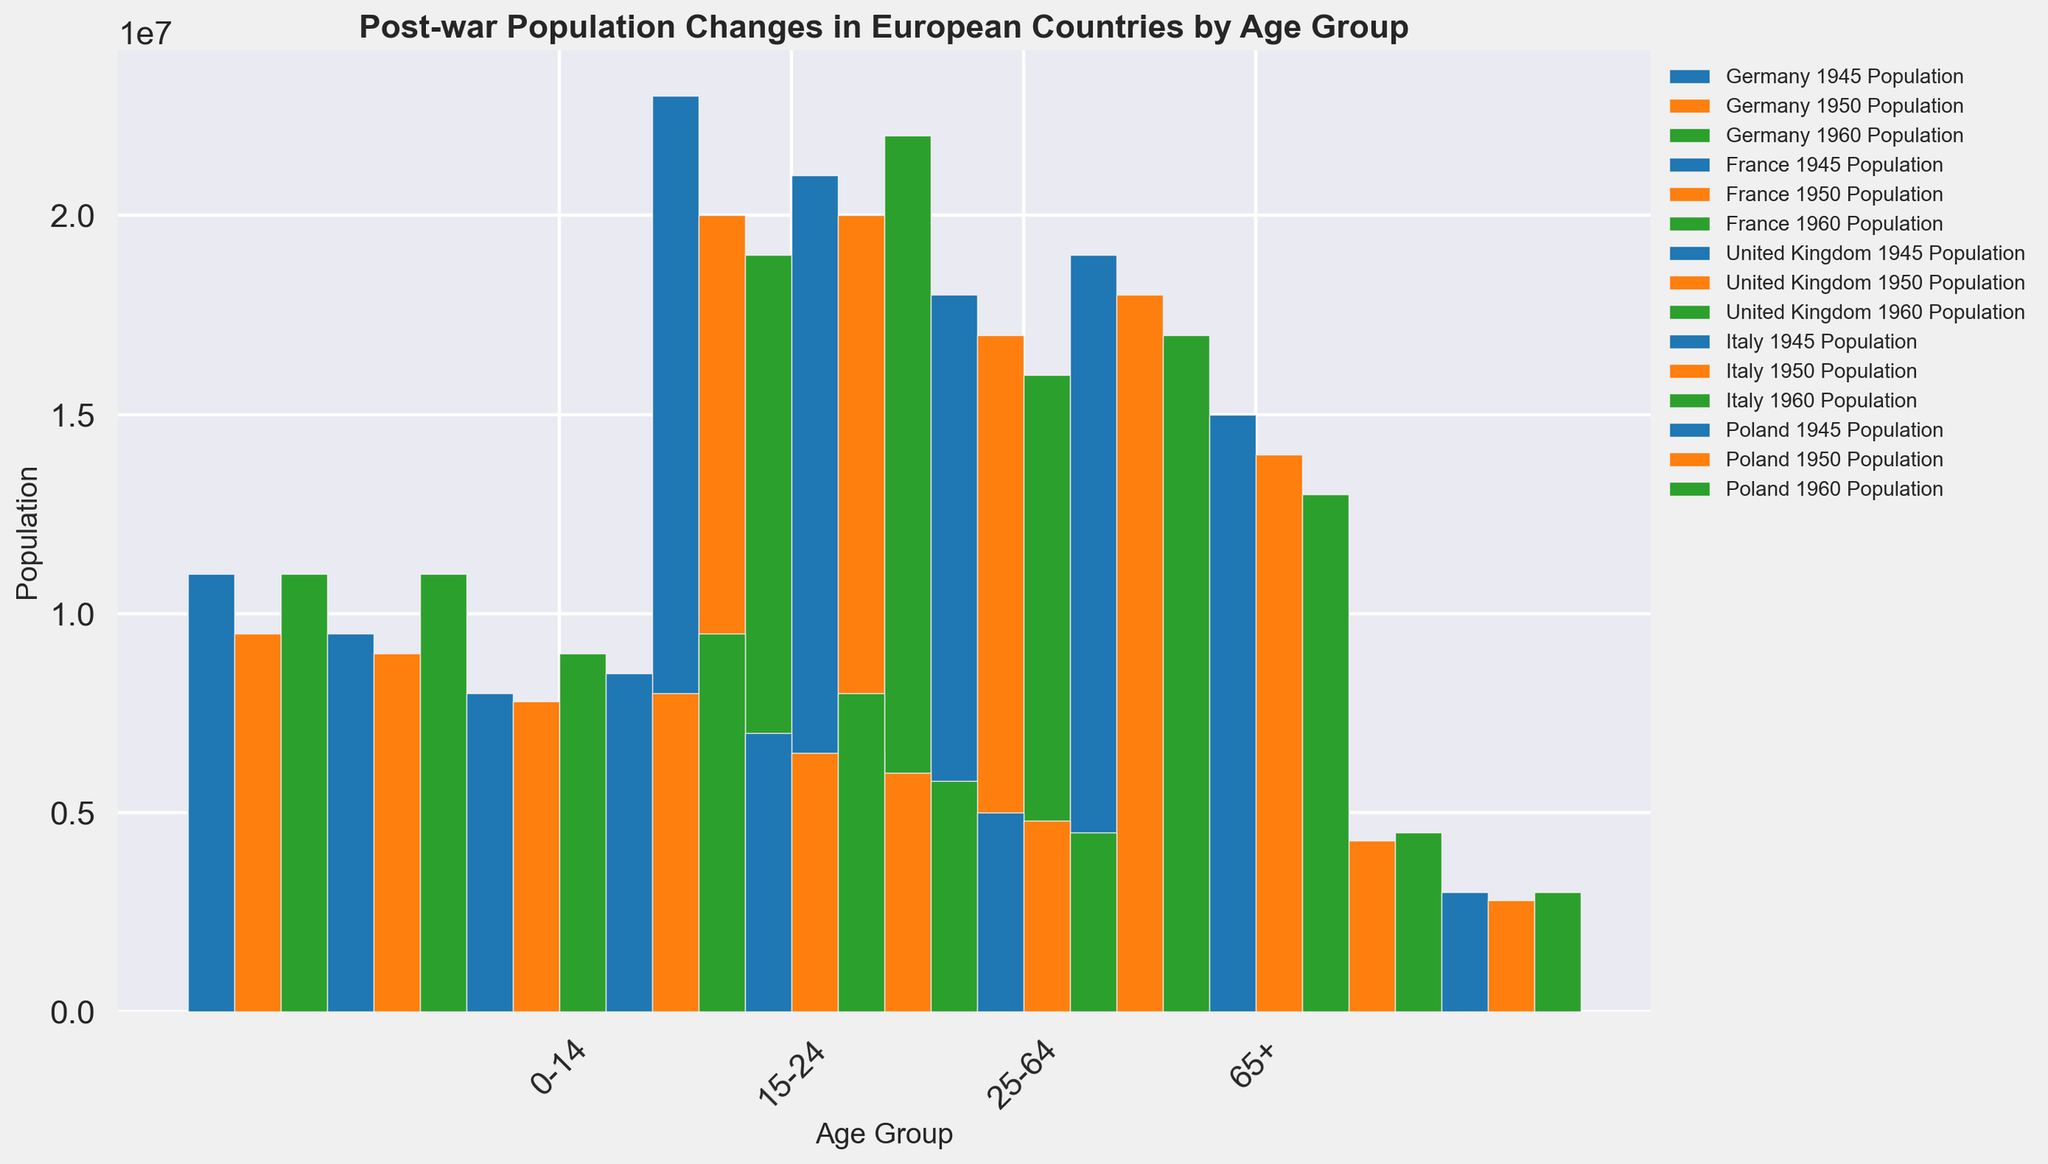Which country had the largest population of the 0-14 age group in 1945? To find the country with the largest population of the 0-14 age group in 1945, look at the bar heights for the 0-14 age group across all countries for the year 1945. Germany has the tallest bar, indicating the largest population among the countries.
Answer: Germany Which country experienced the greatest decline in the 25-64 age group population from 1945 to 1960? Subtract the 1960 population from the 1945 population for the 25-64 age group in each country. For Germany, the decline is 23,000,000 - 19,000,000 = 4,000,000, whereas other countries show a smaller decline.
Answer: Germany What was the total population of the 65+ age group in France across all three years? Sum the populations of the 65+ age group in France for 1945, 1950, and 1960: 5,000,000 + 4,800,000 + 5,000,000. This gives a total of 14,800,000.
Answer: 14,800,000 Which age group in Poland saw the largest increase from 1945 to 1960? Calculate the difference in population for each age group in Poland from 1945 to 1960. For 0-14, it's 8,000,000 - 7,000,000 = 1,000,000. For 15-24, it's 4,500,000 - 5,000,000 = -500,000. For 25-64, it's 13,000,000 - 15,000,000 = -2,000,000. For 65+, it's 3,000,000 - 3,000,000 = 0. The largest increase is in the 0-14 age group.
Answer: 0-14 In 1950, which country had the smallest population in the 15-24 age group? Check the height of the bars representing the 15-24 age group for the year 1950 across all countries. Poland has the bar with the smallest height, representing the smallest population.
Answer: Poland What percentage of the total United Kingdom population in 1945 was in the 25-64 age group? First, calculate the total population of the United Kingdom in 1945 by summing all age groups: 8,000,000 (0-14) + 6,000,000 (15-24) + 18,000,000 (25-64) + 4,000,000 (65+) = 36,000,000. Then, calculate the percentage of the 25-64 age group: (18,000,000 / 36,000,000) * 100 = 50%.
Answer: 50% Between 1950 and 1960, which country saw the largest population growth in the 0-14 age group? Subtract the 1950 population from the 1960 population for the 0-14 age group in each country. In Germany, it's 11,000,000 - 9,500,000 = 1,500,000. In France, it's 11,000,000 - 9,000,000 = 2,000,000. In the United Kingdom, it's 9,000,000 - 7,800,000 = 1,200,000. In Italy, it's 9,500,000 - 8,000,000 = 1,500,000. In Poland, it's 8,000,000 - 6,500,000 = 1,500,000. The largest growth is in France (2,000,000).
Answer: France How does the population of the 65+ age group in Germany in 1960 compare to that of Italy in the same year? Compare the height of the bars for the 65+ age group in Germany and Italy for 1960. Germany has a population of 4,500,000, while Italy has a population of 4,500,000, so they are equal.
Answer: Equal 